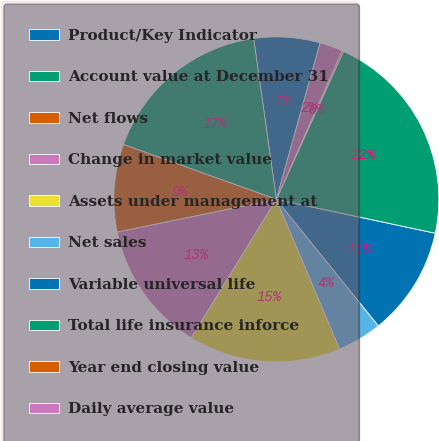Convert chart to OTSL. <chart><loc_0><loc_0><loc_500><loc_500><pie_chart><fcel>Product/Key Indicator<fcel>Account value at December 31<fcel>Net flows<fcel>Change in market value<fcel>Assets under management at<fcel>Net sales<fcel>Variable universal life<fcel>Total life insurance inforce<fcel>Year end closing value<fcel>Daily average value<nl><fcel>6.57%<fcel>17.28%<fcel>8.72%<fcel>13.0%<fcel>15.14%<fcel>4.43%<fcel>10.86%<fcel>21.56%<fcel>0.15%<fcel>2.29%<nl></chart> 